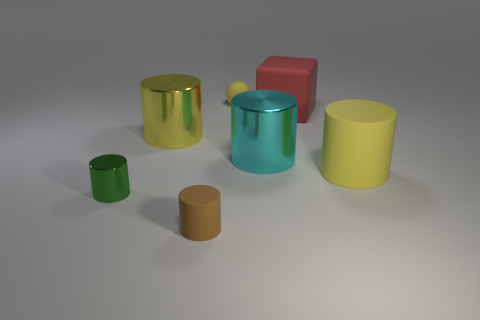Are there fewer big cyan things to the left of the large cyan shiny cylinder than large green matte balls? Upon examining the image, we find that there are no big cyan things to the left of the large cyan shiny cylinder when looking from the stated perspective. Meanwhile, there is exactly one large green matte ball present. This means the answer to your question is no, as one cannot have fewer than zero objects. 